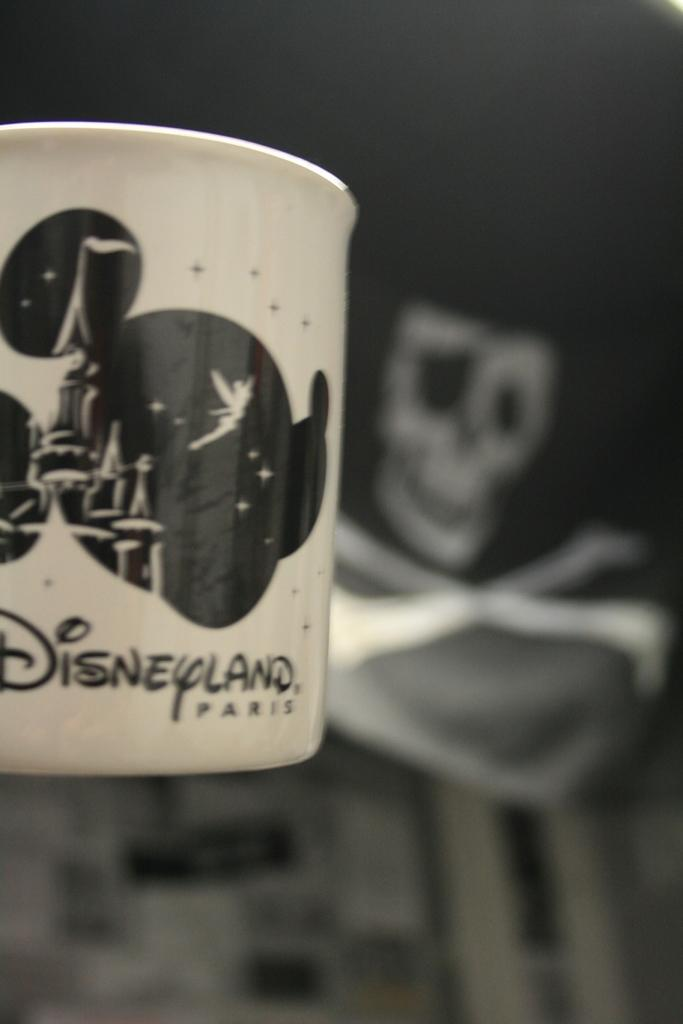<image>
Describe the image concisely. A white and black Mickey mouse design Disneyland Parks coffee mug 